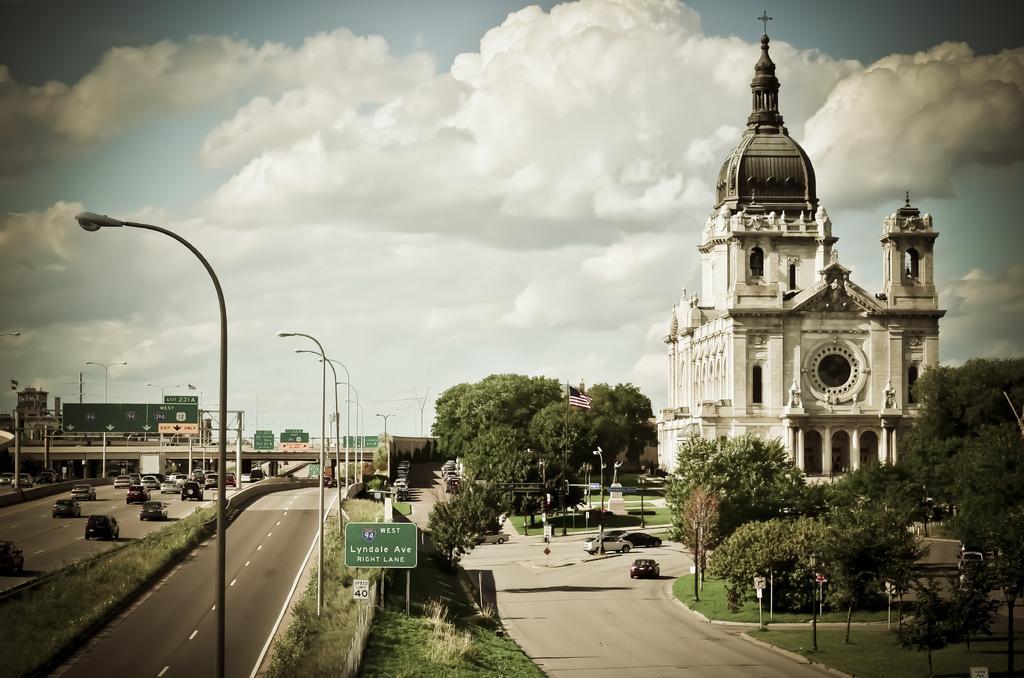Please provide a concise description of this image. In this image, on the right side, we can see a building, trees, plants, vehicles which are moving on the road, flag, pole. In the middle of the image, we can see some street light, hoarding, vehicles which are placed on the road, trees, plants. On the left side, we can also see few vehicles which are moving on the road, pole. In the background, we can see a bridge, hoardings, street light. At the top, we can see a sky which is a bit cloudy, at the bottom, we can see a grass and a road. 